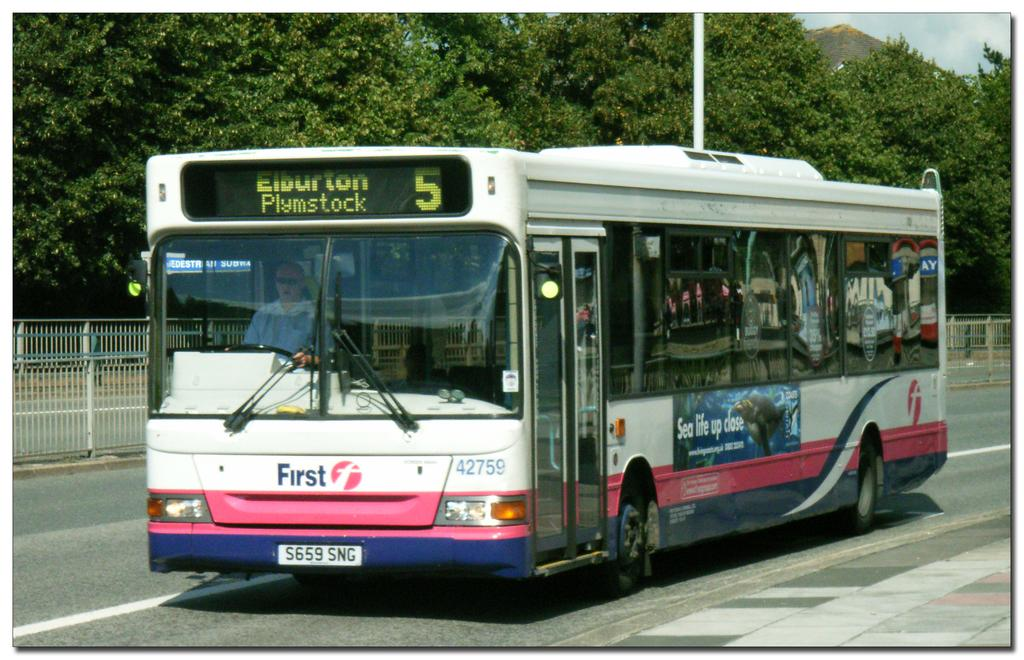What type of vehicle is on the road in the image? There is a bus on the road in the image. Who or what is inside the bus? A man is sitting inside the bus. What is located behind the bus? There is fencing behind the bus. What can be seen behind the fencing? Trees and a pole are visible behind the fencing. How does the yak contribute to the cover of the image? There is no yak present in the image, so it cannot contribute to the cover. 